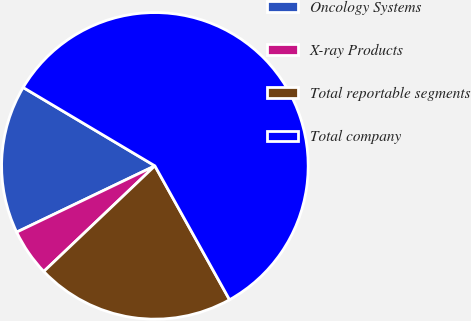Convert chart. <chart><loc_0><loc_0><loc_500><loc_500><pie_chart><fcel>Oncology Systems<fcel>X-ray Products<fcel>Total reportable segments<fcel>Total company<nl><fcel>15.66%<fcel>4.98%<fcel>21.0%<fcel>58.36%<nl></chart> 